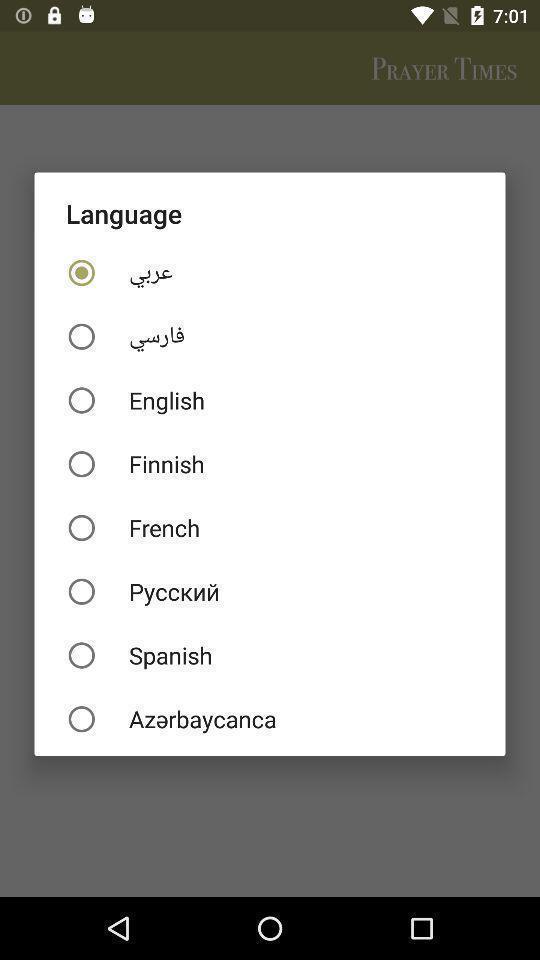What details can you identify in this image? Popup asking to select language in devotional app. 